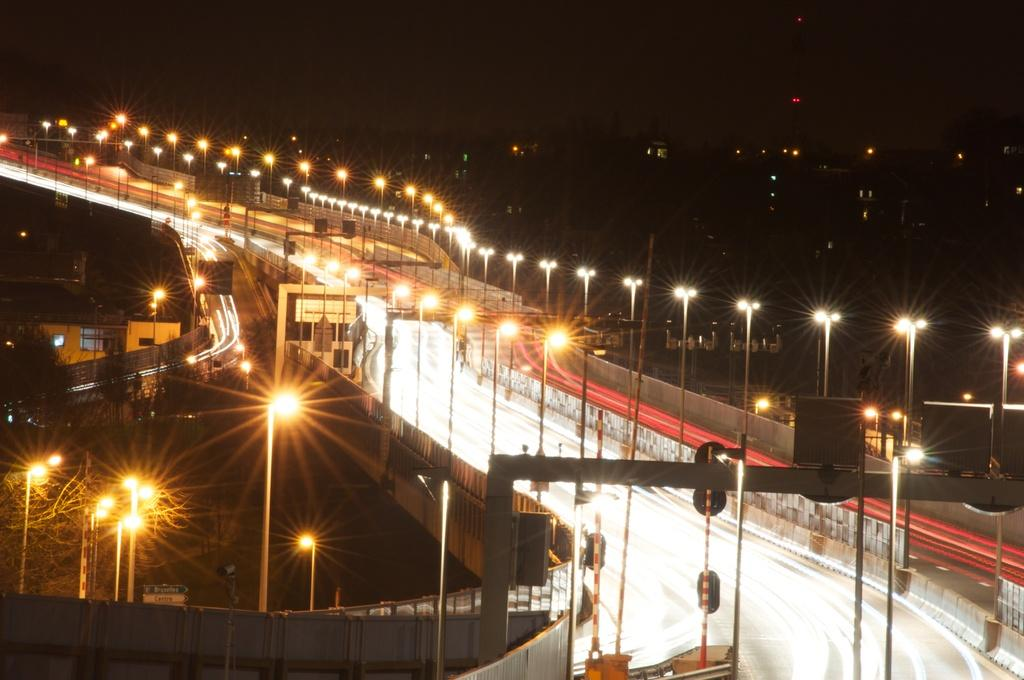What type of structure can be seen in the image? There is a bridge in the image. What other objects are present in the image? There are poles and a metal frame in the bottom right of the image. What can be seen at the top of the image? The sky is visible at the top of the image. What type of shirt is the bridge wearing in the image? Bridges do not wear shirts, as they are inanimate objects. 